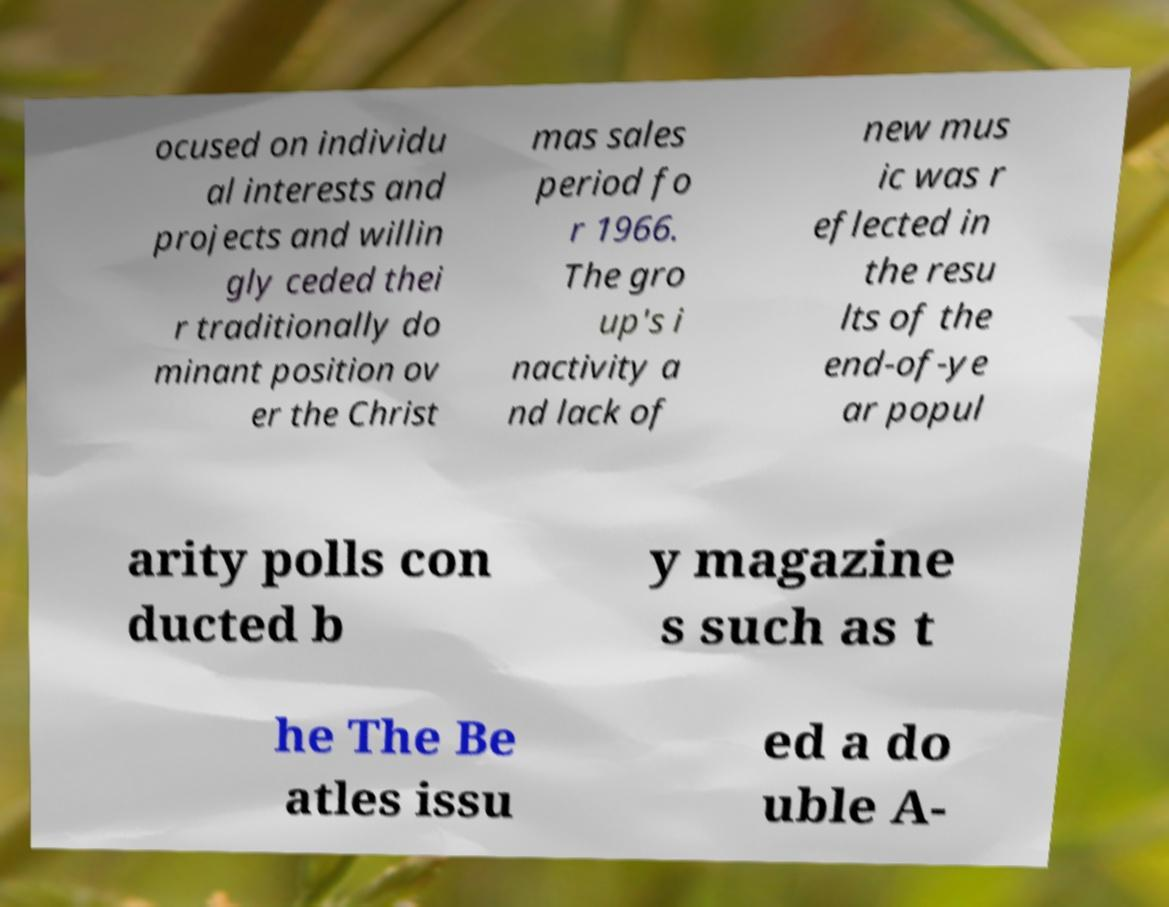What messages or text are displayed in this image? I need them in a readable, typed format. ocused on individu al interests and projects and willin gly ceded thei r traditionally do minant position ov er the Christ mas sales period fo r 1966. The gro up's i nactivity a nd lack of new mus ic was r eflected in the resu lts of the end-of-ye ar popul arity polls con ducted b y magazine s such as t he The Be atles issu ed a do uble A- 